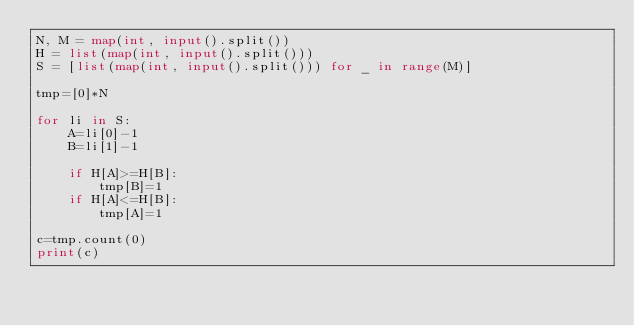Convert code to text. <code><loc_0><loc_0><loc_500><loc_500><_Python_>N, M = map(int, input().split())
H = list(map(int, input().split()))
S = [list(map(int, input().split())) for _ in range(M)]

tmp=[0]*N

for li in S:
    A=li[0]-1
    B=li[1]-1

    if H[A]>=H[B]:
        tmp[B]=1
    if H[A]<=H[B]:
        tmp[A]=1

c=tmp.count(0)
print(c)</code> 